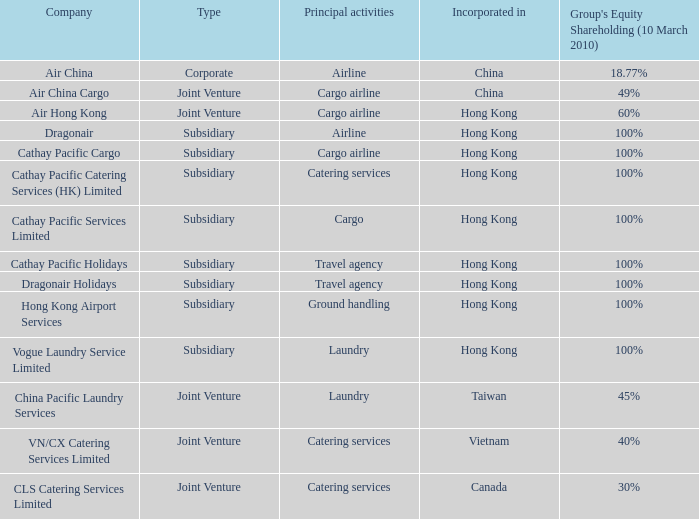Which company primarily focuses on catering services and held a 40% equity shareholding in a group as of march 10th, 2010? VN/CX Catering Services Limited. 